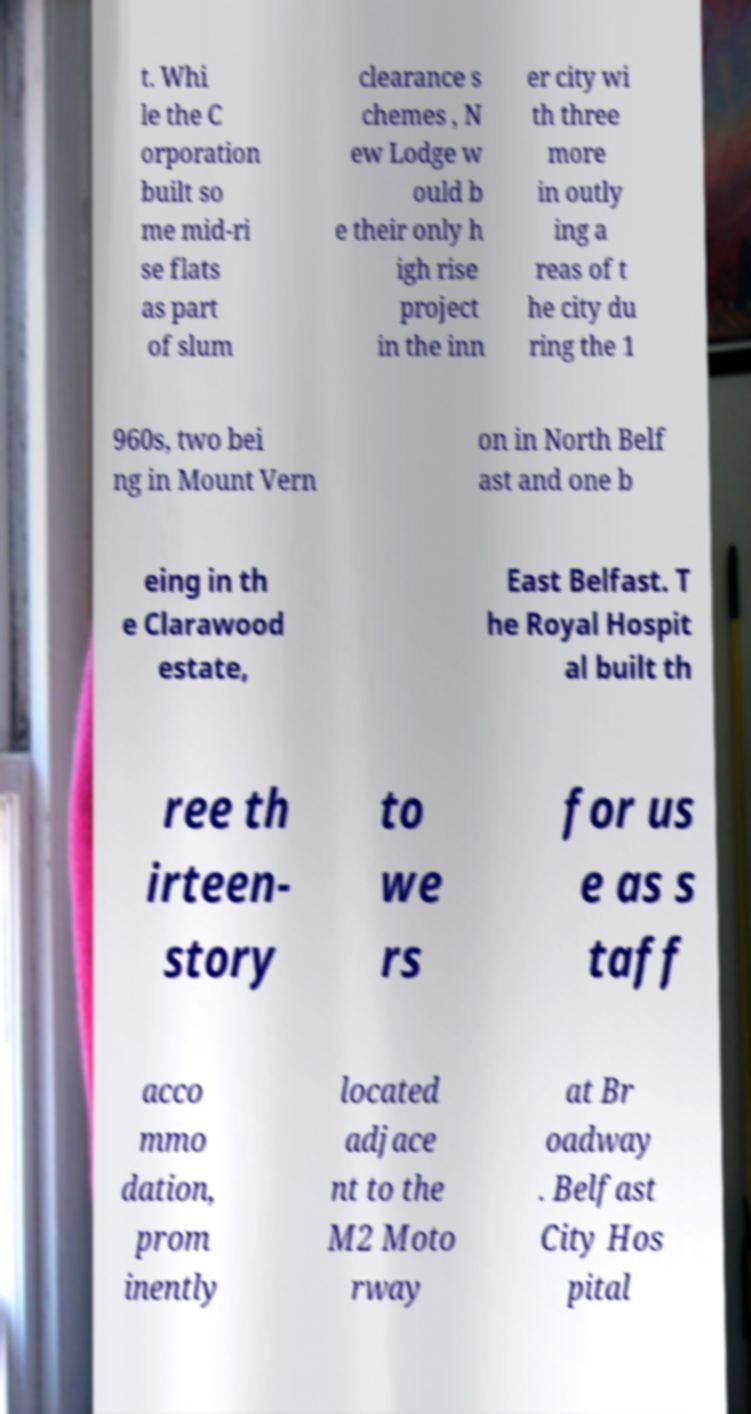For documentation purposes, I need the text within this image transcribed. Could you provide that? t. Whi le the C orporation built so me mid-ri se flats as part of slum clearance s chemes , N ew Lodge w ould b e their only h igh rise project in the inn er city wi th three more in outly ing a reas of t he city du ring the 1 960s, two bei ng in Mount Vern on in North Belf ast and one b eing in th e Clarawood estate, East Belfast. T he Royal Hospit al built th ree th irteen- story to we rs for us e as s taff acco mmo dation, prom inently located adjace nt to the M2 Moto rway at Br oadway . Belfast City Hos pital 